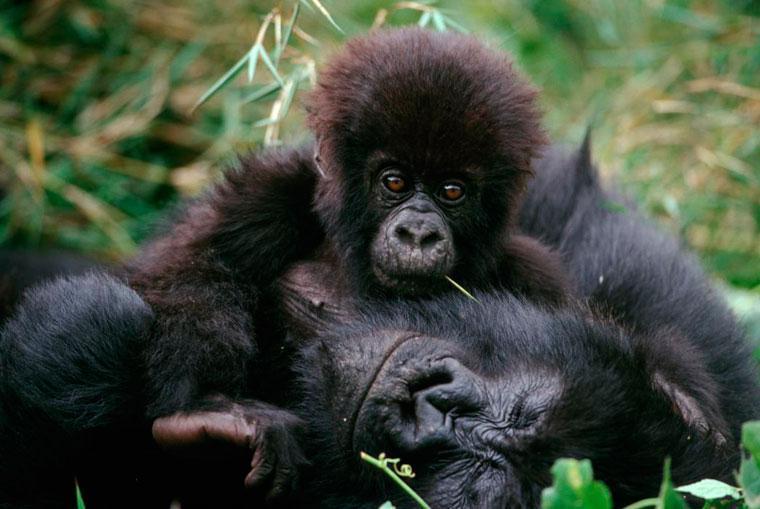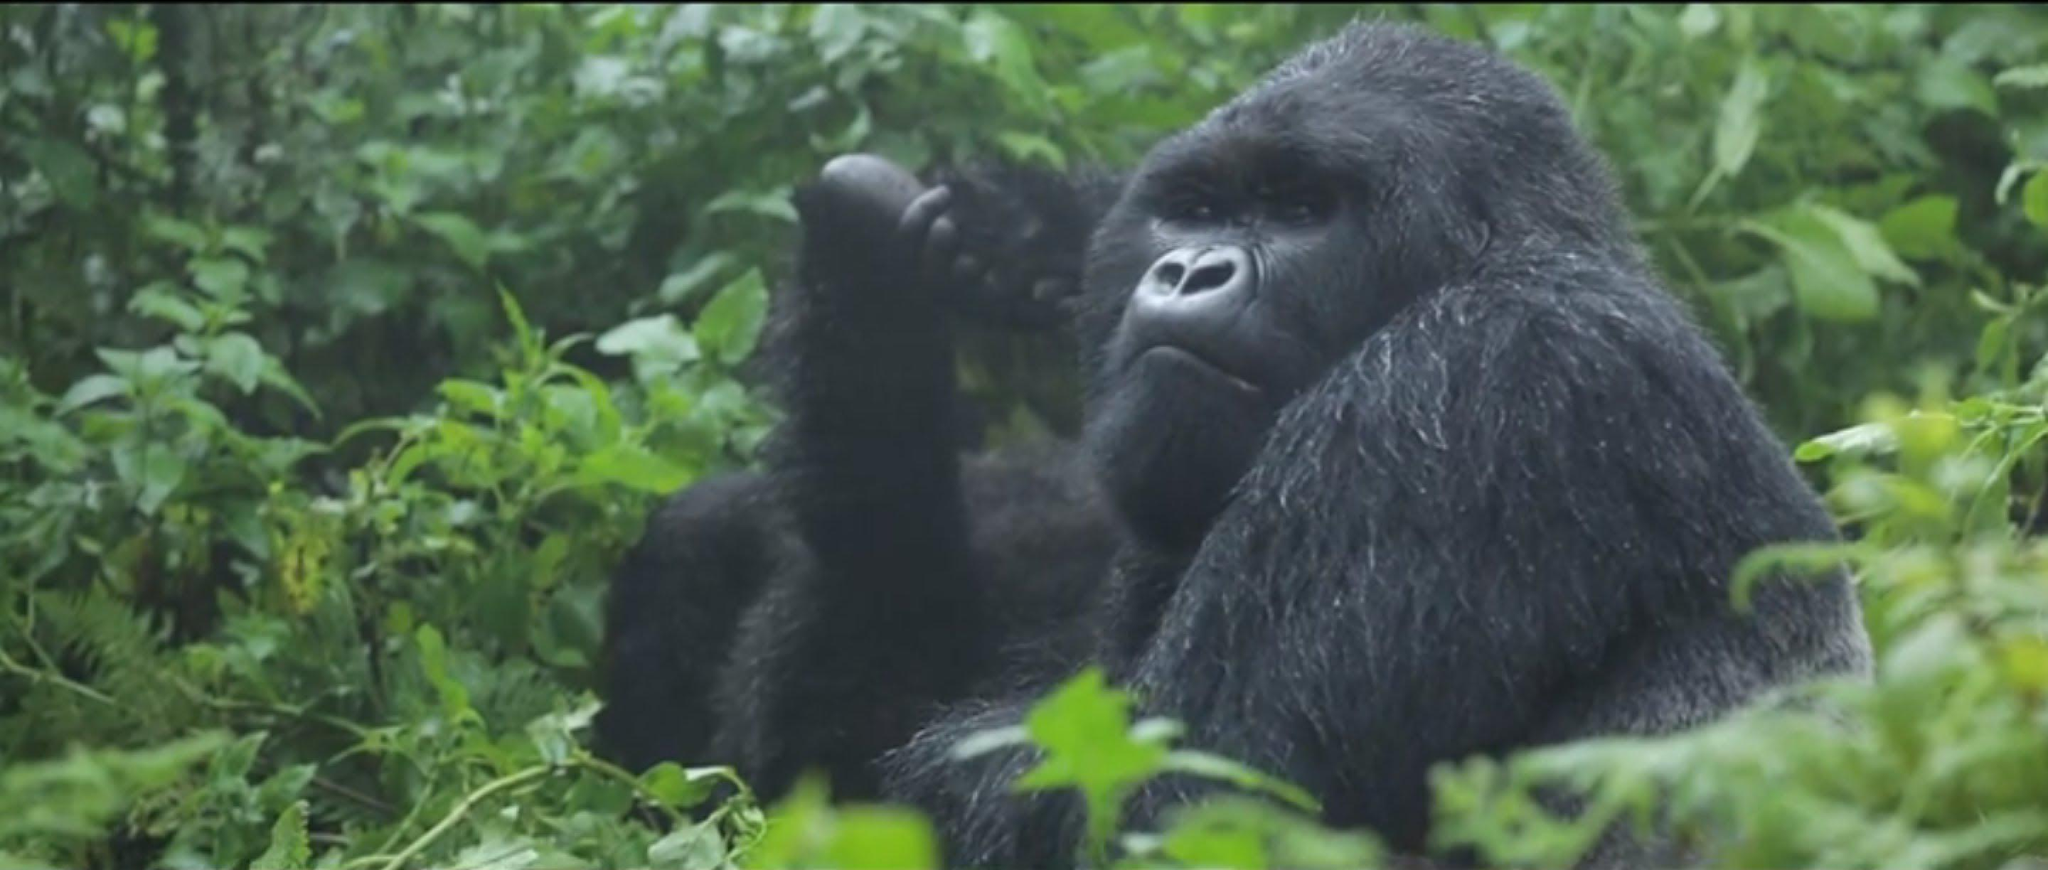The first image is the image on the left, the second image is the image on the right. Evaluate the accuracy of this statement regarding the images: "The right image contains only a baby gorilla with a shock of hair on its head, and the left image includes a baby gorilla on the front of an adult gorilla.". Is it true? Answer yes or no. No. 